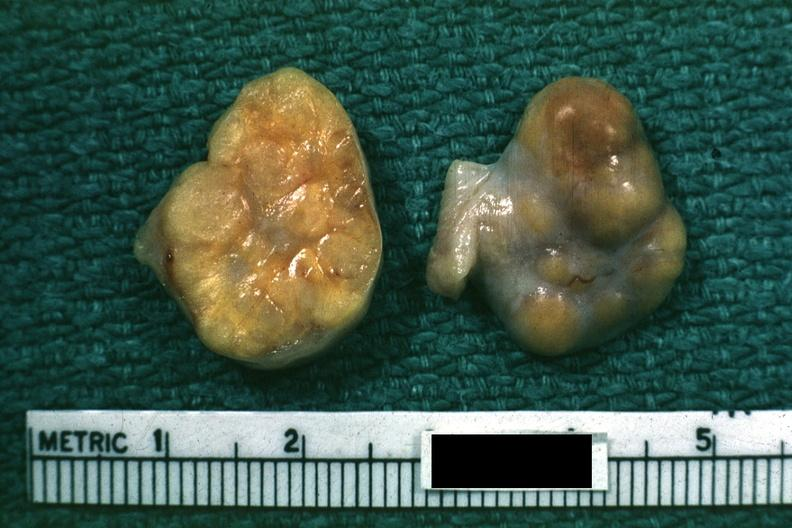s this good yellow color slide labeled granulosa cell tumor?
Answer the question using a single word or phrase. Yes 